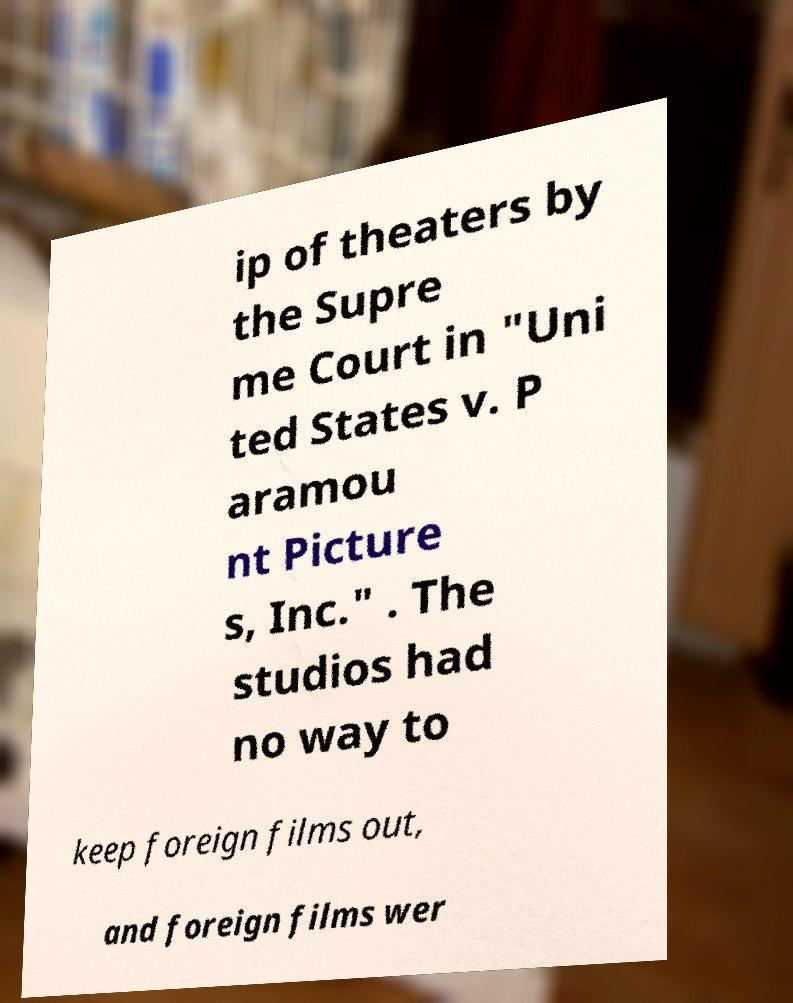For documentation purposes, I need the text within this image transcribed. Could you provide that? ip of theaters by the Supre me Court in "Uni ted States v. P aramou nt Picture s, Inc." . The studios had no way to keep foreign films out, and foreign films wer 